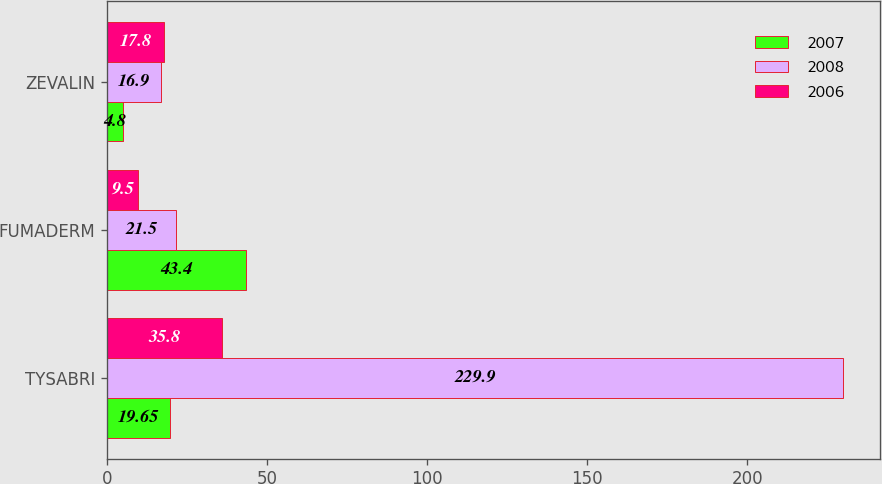Convert chart to OTSL. <chart><loc_0><loc_0><loc_500><loc_500><stacked_bar_chart><ecel><fcel>TYSABRI<fcel>FUMADERM<fcel>ZEVALIN<nl><fcel>2007<fcel>19.65<fcel>43.4<fcel>4.8<nl><fcel>2008<fcel>229.9<fcel>21.5<fcel>16.9<nl><fcel>2006<fcel>35.8<fcel>9.5<fcel>17.8<nl></chart> 